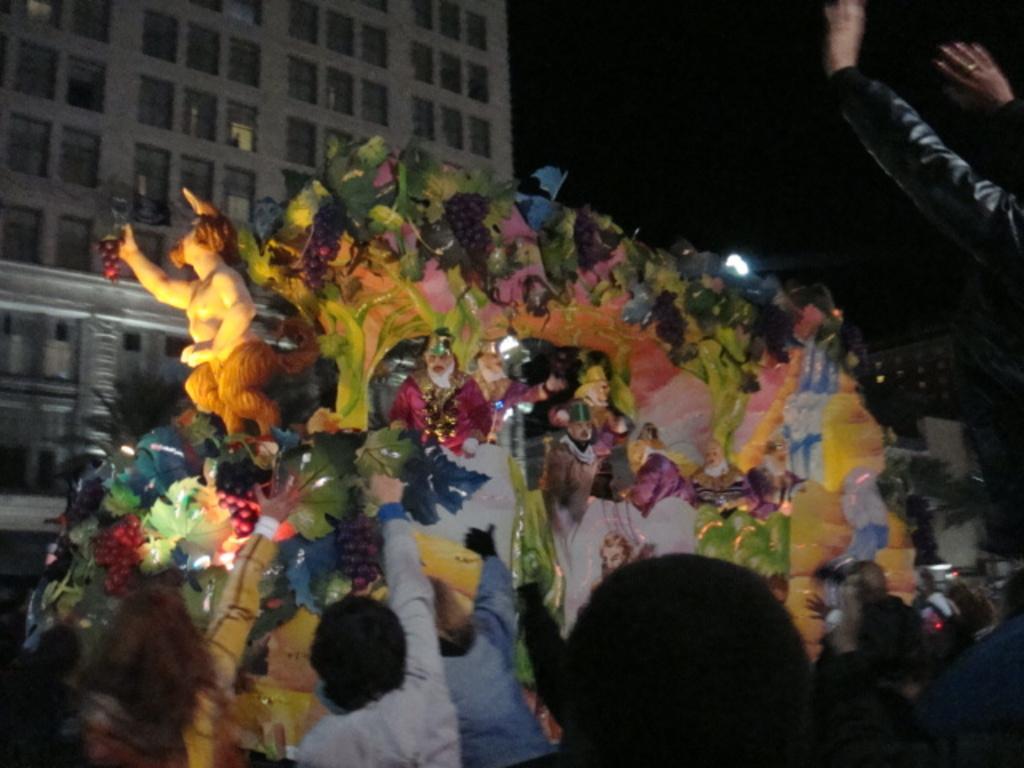Describe this image in one or two sentences. In this image we can see a few people, there are sculptures, and some decorative objects on the vehicle, there is a building, a light, and the background is dark. 